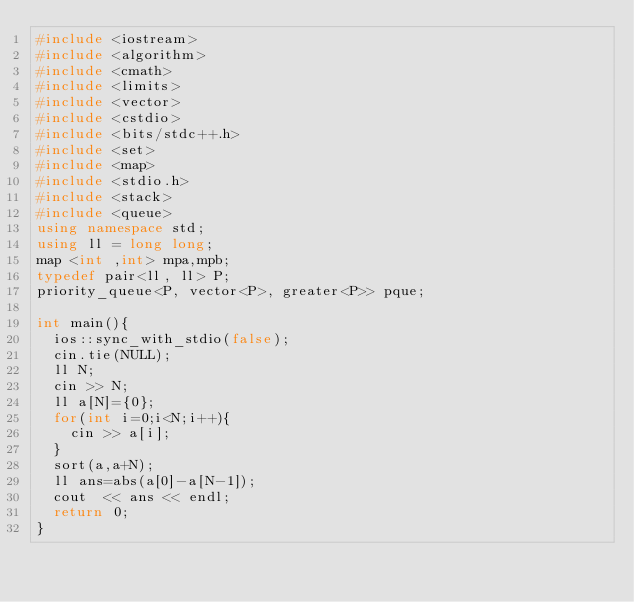Convert code to text. <code><loc_0><loc_0><loc_500><loc_500><_C++_>#include <iostream>
#include <algorithm>
#include <cmath>
#include <limits>
#include <vector>
#include <cstdio>
#include <bits/stdc++.h>
#include <set>
#include <map>
#include <stdio.h>
#include <stack>
#include <queue>
using namespace std;
using ll = long long;
map <int ,int> mpa,mpb;
typedef pair<ll, ll> P;
priority_queue<P, vector<P>, greater<P>> pque;

int main(){
  ios::sync_with_stdio(false);
  cin.tie(NULL);
  ll N;
  cin >> N;
  ll a[N]={0};
  for(int i=0;i<N;i++){
    cin >> a[i];
  }
  sort(a,a+N);
  ll ans=abs(a[0]-a[N-1]);
  cout  << ans << endl;
  return 0;
}</code> 